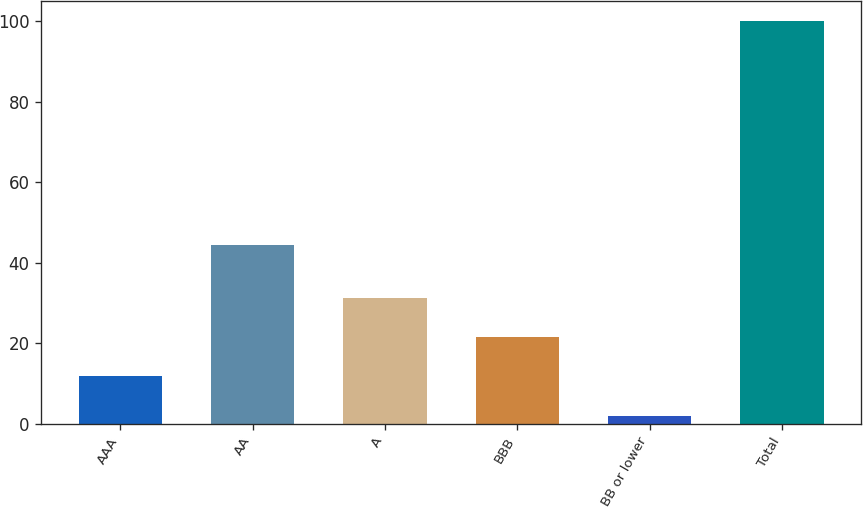Convert chart to OTSL. <chart><loc_0><loc_0><loc_500><loc_500><bar_chart><fcel>AAA<fcel>AA<fcel>A<fcel>BBB<fcel>BB or lower<fcel>Total<nl><fcel>11.71<fcel>44.3<fcel>31.33<fcel>21.52<fcel>1.9<fcel>100<nl></chart> 